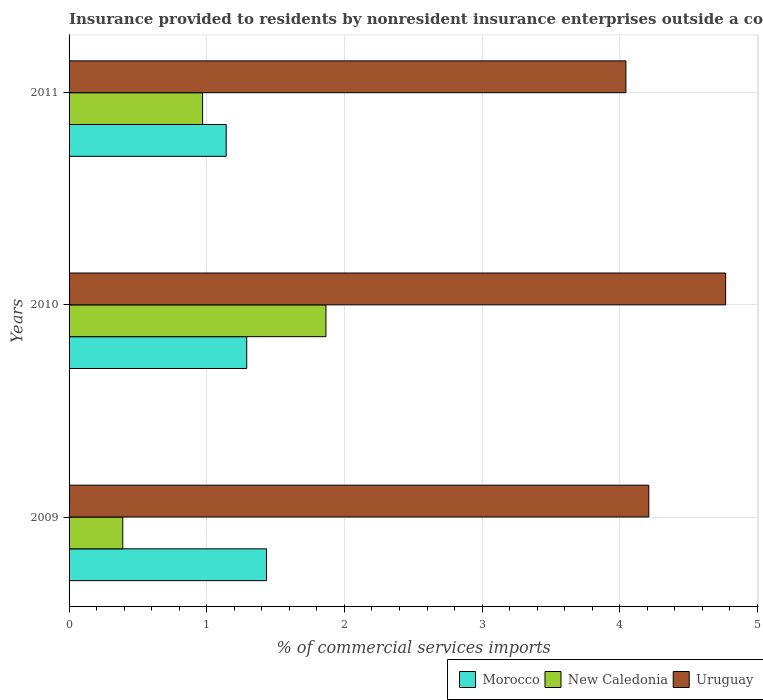How many different coloured bars are there?
Provide a short and direct response. 3. How many bars are there on the 1st tick from the top?
Offer a terse response. 3. What is the label of the 2nd group of bars from the top?
Your response must be concise. 2010. In how many cases, is the number of bars for a given year not equal to the number of legend labels?
Your answer should be compact. 0. What is the Insurance provided to residents in Morocco in 2011?
Your answer should be compact. 1.14. Across all years, what is the maximum Insurance provided to residents in Morocco?
Your answer should be compact. 1.43. Across all years, what is the minimum Insurance provided to residents in Uruguay?
Ensure brevity in your answer.  4.04. In which year was the Insurance provided to residents in Morocco maximum?
Provide a succinct answer. 2009. What is the total Insurance provided to residents in New Caledonia in the graph?
Provide a short and direct response. 3.23. What is the difference between the Insurance provided to residents in Uruguay in 2010 and that in 2011?
Your answer should be compact. 0.72. What is the difference between the Insurance provided to residents in New Caledonia in 2010 and the Insurance provided to residents in Morocco in 2009?
Your answer should be very brief. 0.43. What is the average Insurance provided to residents in Uruguay per year?
Your response must be concise. 4.34. In the year 2010, what is the difference between the Insurance provided to residents in Morocco and Insurance provided to residents in Uruguay?
Provide a short and direct response. -3.48. What is the ratio of the Insurance provided to residents in Morocco in 2009 to that in 2011?
Keep it short and to the point. 1.26. Is the Insurance provided to residents in Uruguay in 2010 less than that in 2011?
Make the answer very short. No. Is the difference between the Insurance provided to residents in Morocco in 2009 and 2011 greater than the difference between the Insurance provided to residents in Uruguay in 2009 and 2011?
Your answer should be very brief. Yes. What is the difference between the highest and the second highest Insurance provided to residents in Uruguay?
Keep it short and to the point. 0.56. What is the difference between the highest and the lowest Insurance provided to residents in Uruguay?
Offer a terse response. 0.72. In how many years, is the Insurance provided to residents in Morocco greater than the average Insurance provided to residents in Morocco taken over all years?
Your answer should be compact. 2. Is the sum of the Insurance provided to residents in Morocco in 2009 and 2010 greater than the maximum Insurance provided to residents in Uruguay across all years?
Make the answer very short. No. What does the 1st bar from the top in 2009 represents?
Give a very brief answer. Uruguay. What does the 1st bar from the bottom in 2010 represents?
Your answer should be compact. Morocco. Is it the case that in every year, the sum of the Insurance provided to residents in Uruguay and Insurance provided to residents in New Caledonia is greater than the Insurance provided to residents in Morocco?
Give a very brief answer. Yes. How many bars are there?
Make the answer very short. 9. What is the difference between two consecutive major ticks on the X-axis?
Your answer should be compact. 1. Does the graph contain any zero values?
Your response must be concise. No. Where does the legend appear in the graph?
Make the answer very short. Bottom right. What is the title of the graph?
Give a very brief answer. Insurance provided to residents by nonresident insurance enterprises outside a country. Does "Iran" appear as one of the legend labels in the graph?
Offer a very short reply. No. What is the label or title of the X-axis?
Give a very brief answer. % of commercial services imports. What is the % of commercial services imports of Morocco in 2009?
Make the answer very short. 1.43. What is the % of commercial services imports of New Caledonia in 2009?
Provide a succinct answer. 0.39. What is the % of commercial services imports in Uruguay in 2009?
Your answer should be very brief. 4.21. What is the % of commercial services imports of Morocco in 2010?
Provide a short and direct response. 1.29. What is the % of commercial services imports in New Caledonia in 2010?
Make the answer very short. 1.87. What is the % of commercial services imports of Uruguay in 2010?
Keep it short and to the point. 4.77. What is the % of commercial services imports in Morocco in 2011?
Provide a succinct answer. 1.14. What is the % of commercial services imports in New Caledonia in 2011?
Provide a succinct answer. 0.97. What is the % of commercial services imports of Uruguay in 2011?
Offer a very short reply. 4.04. Across all years, what is the maximum % of commercial services imports of Morocco?
Provide a succinct answer. 1.43. Across all years, what is the maximum % of commercial services imports of New Caledonia?
Provide a short and direct response. 1.87. Across all years, what is the maximum % of commercial services imports of Uruguay?
Your answer should be compact. 4.77. Across all years, what is the minimum % of commercial services imports of Morocco?
Your response must be concise. 1.14. Across all years, what is the minimum % of commercial services imports of New Caledonia?
Offer a terse response. 0.39. Across all years, what is the minimum % of commercial services imports of Uruguay?
Offer a terse response. 4.04. What is the total % of commercial services imports in Morocco in the graph?
Your answer should be very brief. 3.87. What is the total % of commercial services imports in New Caledonia in the graph?
Offer a terse response. 3.23. What is the total % of commercial services imports of Uruguay in the graph?
Ensure brevity in your answer.  13.02. What is the difference between the % of commercial services imports in Morocco in 2009 and that in 2010?
Provide a succinct answer. 0.14. What is the difference between the % of commercial services imports in New Caledonia in 2009 and that in 2010?
Give a very brief answer. -1.48. What is the difference between the % of commercial services imports in Uruguay in 2009 and that in 2010?
Keep it short and to the point. -0.56. What is the difference between the % of commercial services imports of Morocco in 2009 and that in 2011?
Give a very brief answer. 0.29. What is the difference between the % of commercial services imports of New Caledonia in 2009 and that in 2011?
Your answer should be very brief. -0.58. What is the difference between the % of commercial services imports of Uruguay in 2009 and that in 2011?
Give a very brief answer. 0.17. What is the difference between the % of commercial services imports of Morocco in 2010 and that in 2011?
Your response must be concise. 0.15. What is the difference between the % of commercial services imports of New Caledonia in 2010 and that in 2011?
Your answer should be compact. 0.9. What is the difference between the % of commercial services imports in Uruguay in 2010 and that in 2011?
Provide a short and direct response. 0.72. What is the difference between the % of commercial services imports of Morocco in 2009 and the % of commercial services imports of New Caledonia in 2010?
Your answer should be compact. -0.43. What is the difference between the % of commercial services imports of Morocco in 2009 and the % of commercial services imports of Uruguay in 2010?
Your answer should be very brief. -3.33. What is the difference between the % of commercial services imports in New Caledonia in 2009 and the % of commercial services imports in Uruguay in 2010?
Give a very brief answer. -4.38. What is the difference between the % of commercial services imports in Morocco in 2009 and the % of commercial services imports in New Caledonia in 2011?
Your answer should be very brief. 0.46. What is the difference between the % of commercial services imports of Morocco in 2009 and the % of commercial services imports of Uruguay in 2011?
Make the answer very short. -2.61. What is the difference between the % of commercial services imports of New Caledonia in 2009 and the % of commercial services imports of Uruguay in 2011?
Ensure brevity in your answer.  -3.65. What is the difference between the % of commercial services imports in Morocco in 2010 and the % of commercial services imports in New Caledonia in 2011?
Provide a succinct answer. 0.32. What is the difference between the % of commercial services imports in Morocco in 2010 and the % of commercial services imports in Uruguay in 2011?
Make the answer very short. -2.75. What is the difference between the % of commercial services imports in New Caledonia in 2010 and the % of commercial services imports in Uruguay in 2011?
Your answer should be compact. -2.18. What is the average % of commercial services imports of Morocco per year?
Offer a terse response. 1.29. What is the average % of commercial services imports of New Caledonia per year?
Keep it short and to the point. 1.08. What is the average % of commercial services imports in Uruguay per year?
Make the answer very short. 4.34. In the year 2009, what is the difference between the % of commercial services imports of Morocco and % of commercial services imports of New Caledonia?
Make the answer very short. 1.04. In the year 2009, what is the difference between the % of commercial services imports of Morocco and % of commercial services imports of Uruguay?
Provide a short and direct response. -2.78. In the year 2009, what is the difference between the % of commercial services imports in New Caledonia and % of commercial services imports in Uruguay?
Provide a short and direct response. -3.82. In the year 2010, what is the difference between the % of commercial services imports of Morocco and % of commercial services imports of New Caledonia?
Provide a short and direct response. -0.58. In the year 2010, what is the difference between the % of commercial services imports in Morocco and % of commercial services imports in Uruguay?
Your answer should be compact. -3.48. In the year 2010, what is the difference between the % of commercial services imports in New Caledonia and % of commercial services imports in Uruguay?
Keep it short and to the point. -2.9. In the year 2011, what is the difference between the % of commercial services imports of Morocco and % of commercial services imports of New Caledonia?
Your answer should be compact. 0.17. In the year 2011, what is the difference between the % of commercial services imports in Morocco and % of commercial services imports in Uruguay?
Provide a succinct answer. -2.9. In the year 2011, what is the difference between the % of commercial services imports in New Caledonia and % of commercial services imports in Uruguay?
Offer a very short reply. -3.07. What is the ratio of the % of commercial services imports in Morocco in 2009 to that in 2010?
Your answer should be very brief. 1.11. What is the ratio of the % of commercial services imports in New Caledonia in 2009 to that in 2010?
Ensure brevity in your answer.  0.21. What is the ratio of the % of commercial services imports of Uruguay in 2009 to that in 2010?
Your answer should be very brief. 0.88. What is the ratio of the % of commercial services imports in Morocco in 2009 to that in 2011?
Make the answer very short. 1.26. What is the ratio of the % of commercial services imports of New Caledonia in 2009 to that in 2011?
Provide a succinct answer. 0.4. What is the ratio of the % of commercial services imports in Uruguay in 2009 to that in 2011?
Ensure brevity in your answer.  1.04. What is the ratio of the % of commercial services imports in Morocco in 2010 to that in 2011?
Give a very brief answer. 1.13. What is the ratio of the % of commercial services imports in New Caledonia in 2010 to that in 2011?
Give a very brief answer. 1.92. What is the ratio of the % of commercial services imports of Uruguay in 2010 to that in 2011?
Keep it short and to the point. 1.18. What is the difference between the highest and the second highest % of commercial services imports in Morocco?
Give a very brief answer. 0.14. What is the difference between the highest and the second highest % of commercial services imports in New Caledonia?
Make the answer very short. 0.9. What is the difference between the highest and the second highest % of commercial services imports of Uruguay?
Your answer should be very brief. 0.56. What is the difference between the highest and the lowest % of commercial services imports in Morocco?
Offer a very short reply. 0.29. What is the difference between the highest and the lowest % of commercial services imports in New Caledonia?
Your answer should be compact. 1.48. What is the difference between the highest and the lowest % of commercial services imports in Uruguay?
Provide a succinct answer. 0.72. 